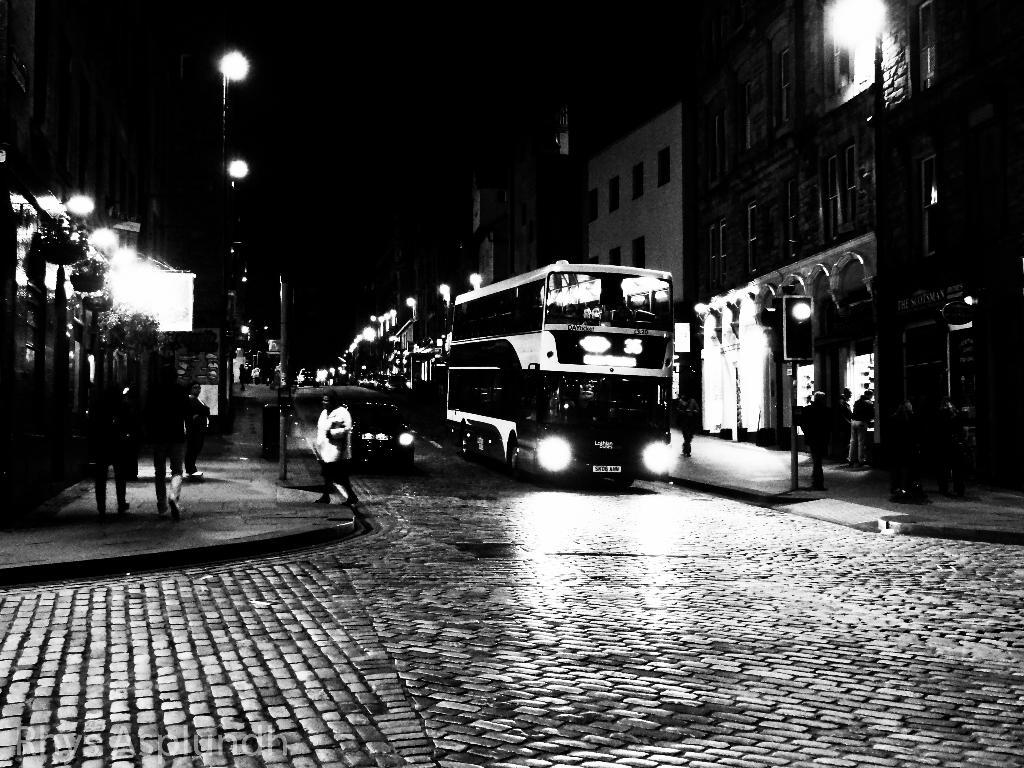What can be seen on the road in the image? There are vehicles on the road in the image. What can be seen on the footpath in the image? There are people on the footpath in the image. What structures are present in the image? There are poles, lights, and buildings in the image. What else can be seen in the image? There are some objects in the image. How would you describe the background of the image? The background of the image is dark. Can you tell me how many roses are on the hospital bed in the image? There is no hospital bed or rose present in the image. What type of bird can be seen flying near the wren in the image? There is no wren or bird present in the image. 